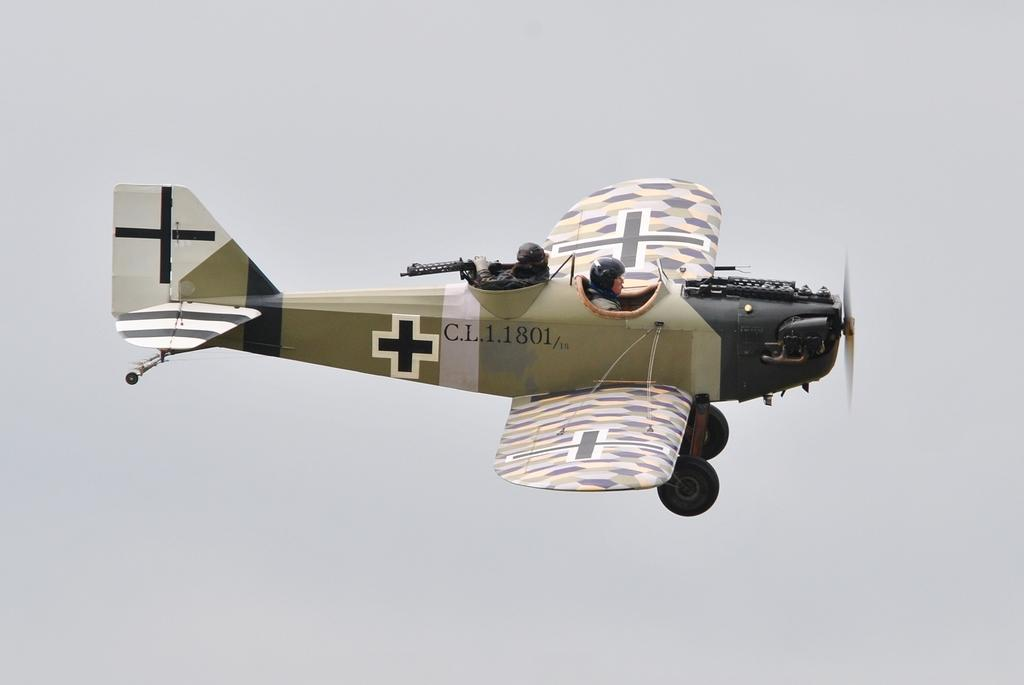What is the main subject of the image? The main subject of the image is an aircraft. Can you describe the people in the image? There are two persons in the image. What can be seen in the background of the image? The sky is visible in the background of the image. What type of skirt is the egg wearing in the image? There is no egg or skirt present in the image. 